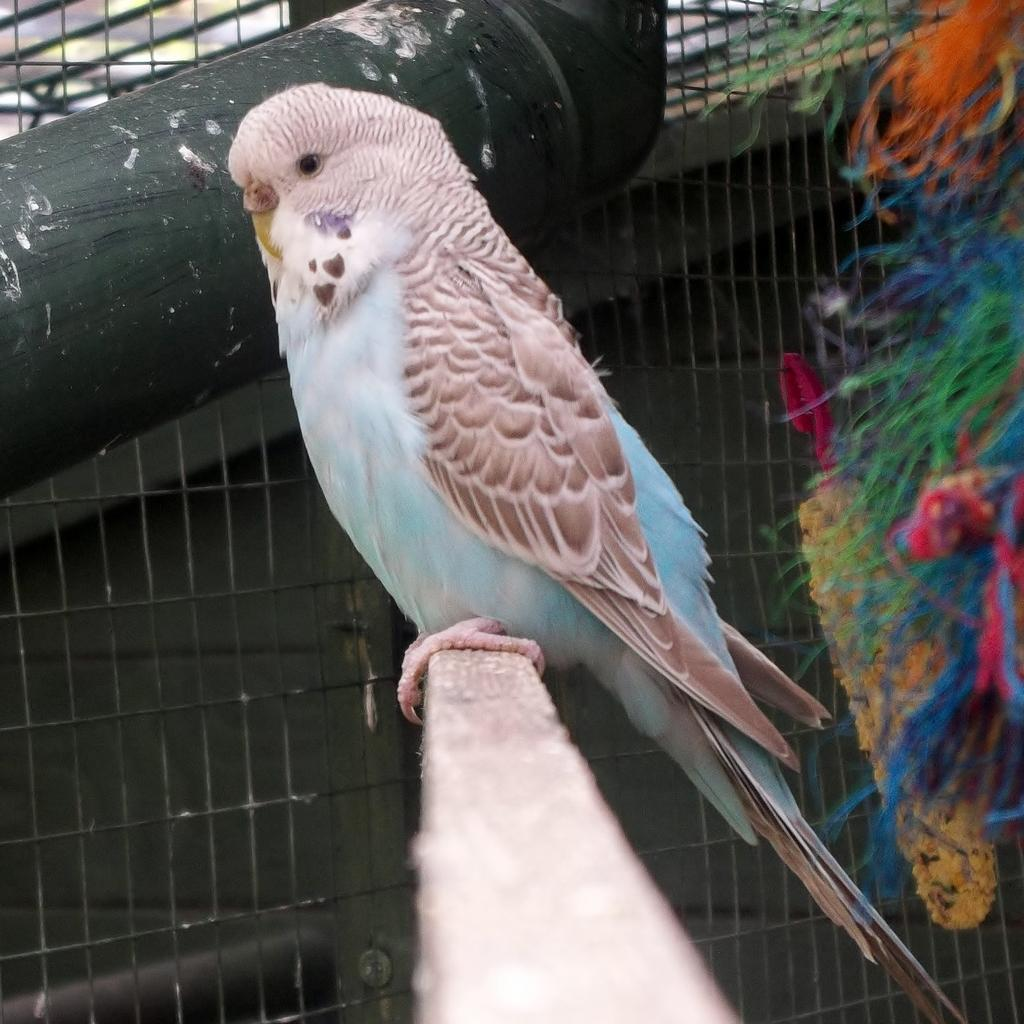What type of animal is in the image? There is a bird in the image. What is the bird standing on? The bird is on a wooden surface. What can be seen in the background of the image? There is a mesh, a pipe, and a colorful object in the background of the image. What type of plastic object is being smashed by the bird in the image? There is no plastic object or any indication of smashing in the image; it features a bird on a wooden surface with a mesh, pipe, and colorful object in the background. 